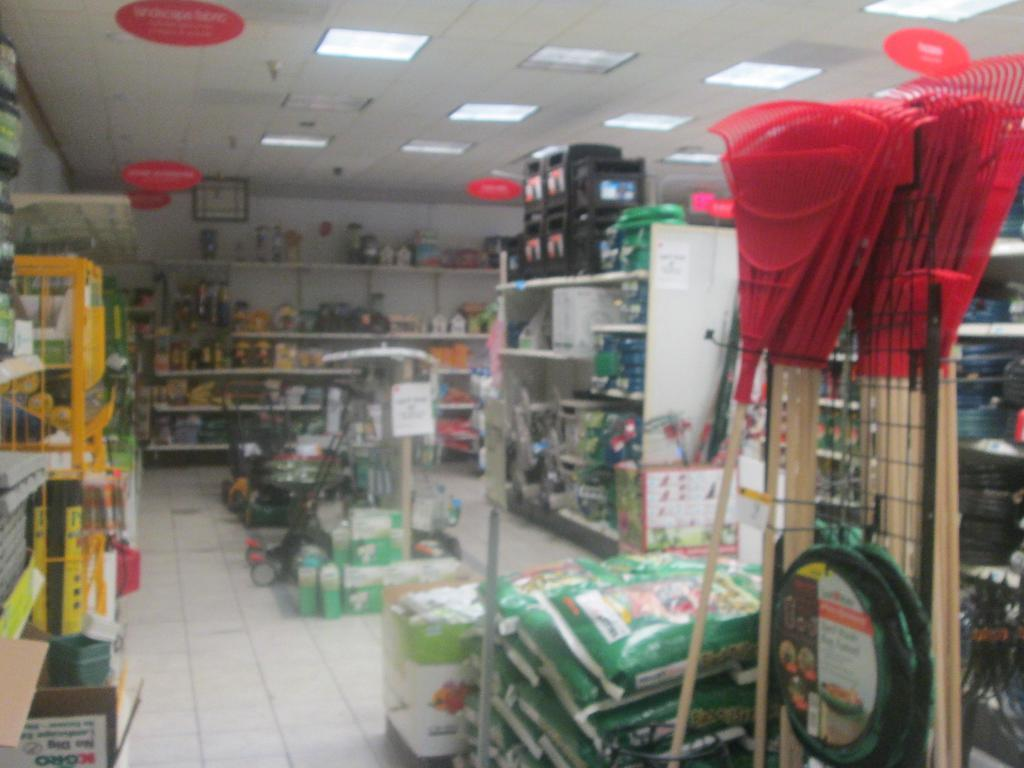What is the perspective of the image? The image is taken from inside. What can be seen on the floor in the image? There are objects placed on the floor in the image. How are some objects arranged in the image? Some objects are arranged in a rack in the image. What is visible at the top of the image? There is a ceiling visible at the top of the image. What type of wrist injury can be seen in the image? There is no wrist injury present in the image. What happens to the pail when it bursts in the image? There is no pail or bursting event present in the image. 